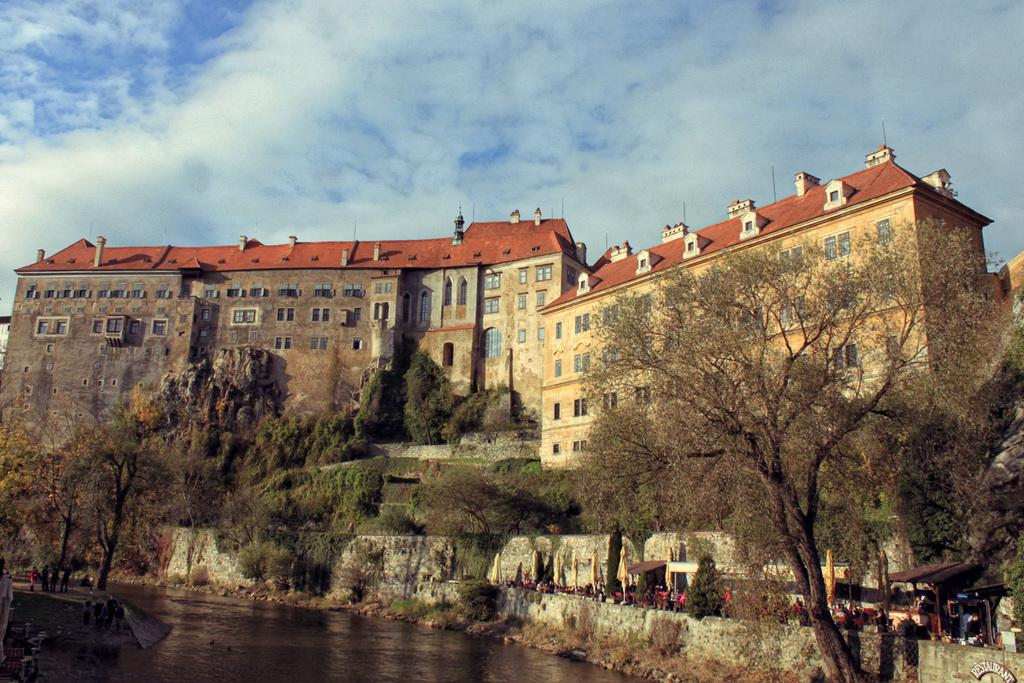What is present at the front of the image? There is water in the front of the image. What can be seen in the middle of the image? There are three trees and persons in the center of the image. What is visible in the background of the image? There are buildings in the background of the image. How would you describe the sky in the image? The sky is cloudy. What type of calculator is being used by the persons in the image? There is no calculator present in the image; it features trees, persons, water, buildings, and a cloudy sky. What meal are the persons eating in the image? There is no meal being eaten in the image; it only shows trees, persons, water, buildings, and a cloudy sky. 